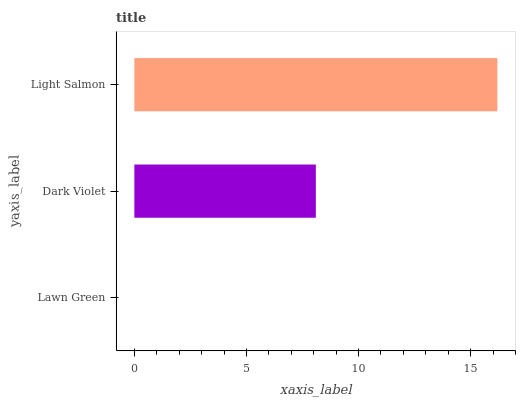Is Lawn Green the minimum?
Answer yes or no. Yes. Is Light Salmon the maximum?
Answer yes or no. Yes. Is Dark Violet the minimum?
Answer yes or no. No. Is Dark Violet the maximum?
Answer yes or no. No. Is Dark Violet greater than Lawn Green?
Answer yes or no. Yes. Is Lawn Green less than Dark Violet?
Answer yes or no. Yes. Is Lawn Green greater than Dark Violet?
Answer yes or no. No. Is Dark Violet less than Lawn Green?
Answer yes or no. No. Is Dark Violet the high median?
Answer yes or no. Yes. Is Dark Violet the low median?
Answer yes or no. Yes. Is Lawn Green the high median?
Answer yes or no. No. Is Light Salmon the low median?
Answer yes or no. No. 